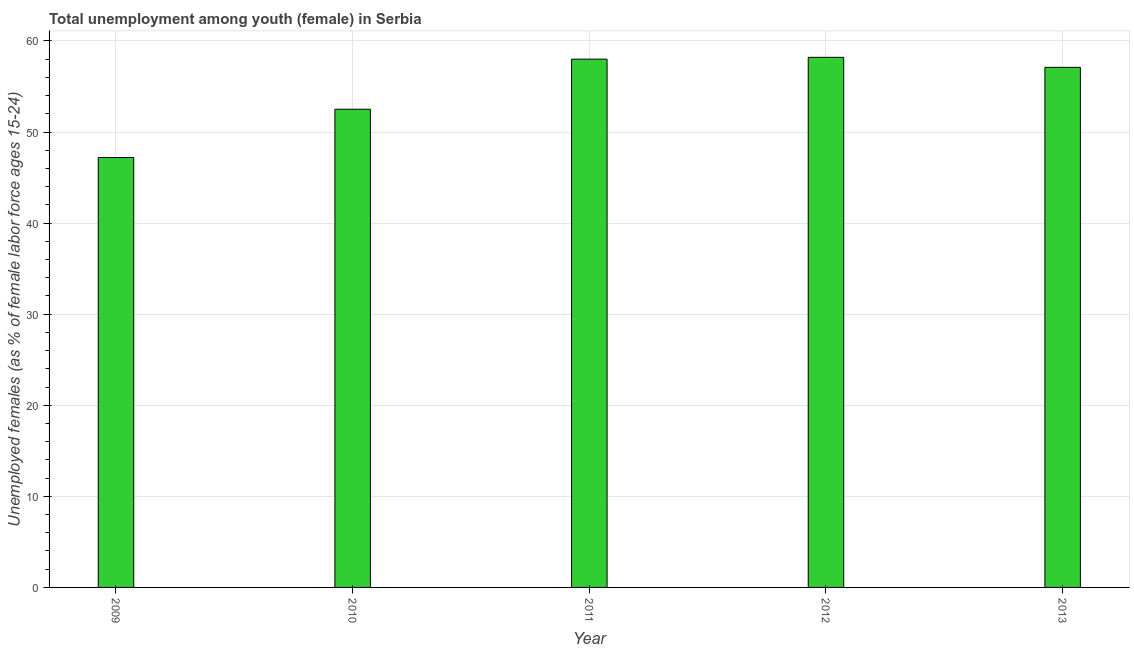Does the graph contain any zero values?
Keep it short and to the point. No. Does the graph contain grids?
Your answer should be compact. Yes. What is the title of the graph?
Make the answer very short. Total unemployment among youth (female) in Serbia. What is the label or title of the Y-axis?
Your response must be concise. Unemployed females (as % of female labor force ages 15-24). What is the unemployed female youth population in 2013?
Keep it short and to the point. 57.1. Across all years, what is the maximum unemployed female youth population?
Give a very brief answer. 58.2. Across all years, what is the minimum unemployed female youth population?
Make the answer very short. 47.2. In which year was the unemployed female youth population minimum?
Offer a very short reply. 2009. What is the sum of the unemployed female youth population?
Your answer should be very brief. 273. What is the average unemployed female youth population per year?
Give a very brief answer. 54.6. What is the median unemployed female youth population?
Offer a very short reply. 57.1. In how many years, is the unemployed female youth population greater than 14 %?
Provide a succinct answer. 5. Do a majority of the years between 2011 and 2012 (inclusive) have unemployed female youth population greater than 50 %?
Provide a succinct answer. Yes. What is the ratio of the unemployed female youth population in 2011 to that in 2012?
Keep it short and to the point. 1. Is the unemployed female youth population in 2009 less than that in 2011?
Ensure brevity in your answer.  Yes. Is the difference between the unemployed female youth population in 2009 and 2013 greater than the difference between any two years?
Your answer should be compact. No. Is the sum of the unemployed female youth population in 2009 and 2012 greater than the maximum unemployed female youth population across all years?
Give a very brief answer. Yes. What is the difference between the highest and the lowest unemployed female youth population?
Offer a very short reply. 11. How many bars are there?
Your answer should be very brief. 5. Are all the bars in the graph horizontal?
Provide a succinct answer. No. How many years are there in the graph?
Give a very brief answer. 5. What is the difference between two consecutive major ticks on the Y-axis?
Provide a succinct answer. 10. What is the Unemployed females (as % of female labor force ages 15-24) in 2009?
Offer a terse response. 47.2. What is the Unemployed females (as % of female labor force ages 15-24) in 2010?
Give a very brief answer. 52.5. What is the Unemployed females (as % of female labor force ages 15-24) in 2012?
Provide a short and direct response. 58.2. What is the Unemployed females (as % of female labor force ages 15-24) of 2013?
Keep it short and to the point. 57.1. What is the difference between the Unemployed females (as % of female labor force ages 15-24) in 2009 and 2012?
Provide a short and direct response. -11. What is the difference between the Unemployed females (as % of female labor force ages 15-24) in 2010 and 2012?
Provide a succinct answer. -5.7. What is the difference between the Unemployed females (as % of female labor force ages 15-24) in 2010 and 2013?
Provide a short and direct response. -4.6. What is the difference between the Unemployed females (as % of female labor force ages 15-24) in 2012 and 2013?
Keep it short and to the point. 1.1. What is the ratio of the Unemployed females (as % of female labor force ages 15-24) in 2009 to that in 2010?
Your answer should be very brief. 0.9. What is the ratio of the Unemployed females (as % of female labor force ages 15-24) in 2009 to that in 2011?
Your response must be concise. 0.81. What is the ratio of the Unemployed females (as % of female labor force ages 15-24) in 2009 to that in 2012?
Provide a succinct answer. 0.81. What is the ratio of the Unemployed females (as % of female labor force ages 15-24) in 2009 to that in 2013?
Keep it short and to the point. 0.83. What is the ratio of the Unemployed females (as % of female labor force ages 15-24) in 2010 to that in 2011?
Offer a terse response. 0.91. What is the ratio of the Unemployed females (as % of female labor force ages 15-24) in 2010 to that in 2012?
Keep it short and to the point. 0.9. What is the ratio of the Unemployed females (as % of female labor force ages 15-24) in 2010 to that in 2013?
Keep it short and to the point. 0.92. What is the ratio of the Unemployed females (as % of female labor force ages 15-24) in 2011 to that in 2012?
Offer a very short reply. 1. What is the ratio of the Unemployed females (as % of female labor force ages 15-24) in 2011 to that in 2013?
Provide a short and direct response. 1.02. 